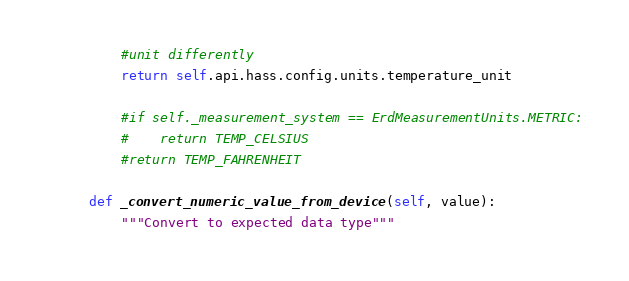<code> <loc_0><loc_0><loc_500><loc_500><_Python_>        #unit differently
        return self.api.hass.config.units.temperature_unit

        #if self._measurement_system == ErdMeasurementUnits.METRIC:
        #    return TEMP_CELSIUS
        #return TEMP_FAHRENHEIT

    def _convert_numeric_value_from_device(self, value):
        """Convert to expected data type"""
</code> 